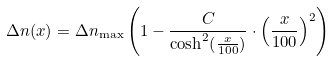<formula> <loc_0><loc_0><loc_500><loc_500>\Delta n ( x ) = \Delta n _ { \max } \left ( 1 - \frac { C } { \cosh ^ { 2 } ( \frac { x } { 1 0 0 } ) } \cdot \left ( \frac { x } { 1 0 0 } \right ) ^ { 2 } \right )</formula> 